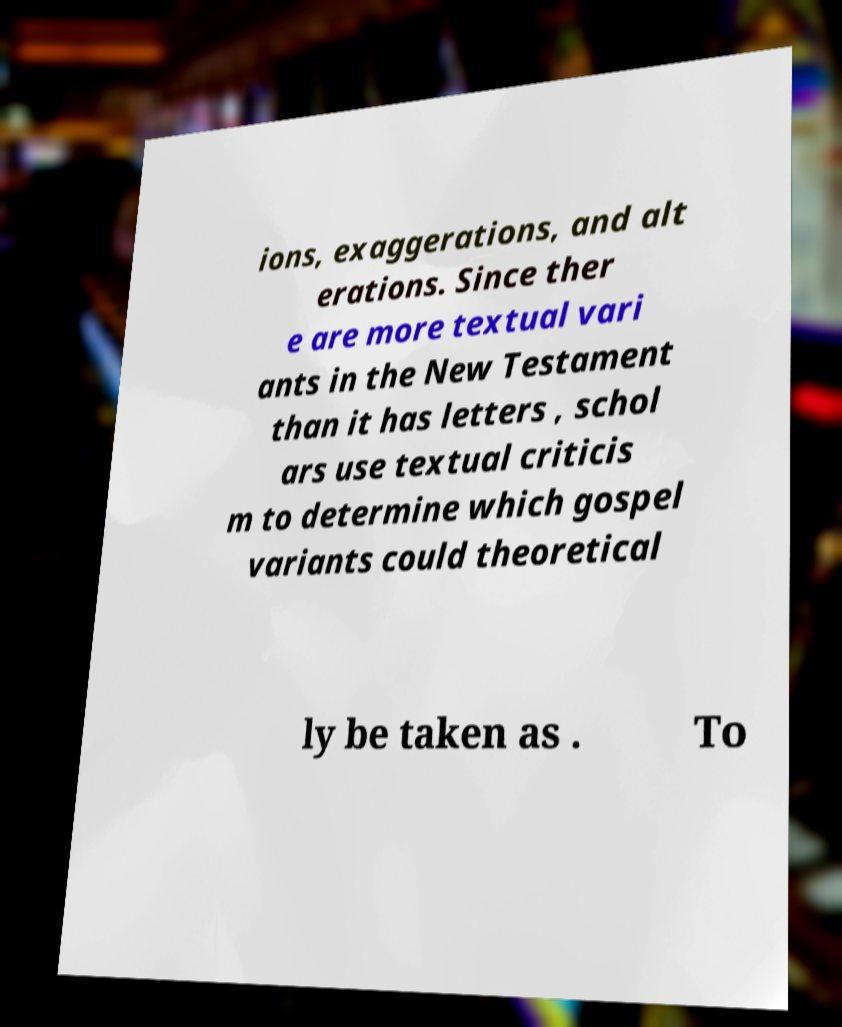I need the written content from this picture converted into text. Can you do that? ions, exaggerations, and alt erations. Since ther e are more textual vari ants in the New Testament than it has letters , schol ars use textual criticis m to determine which gospel variants could theoretical ly be taken as . To 